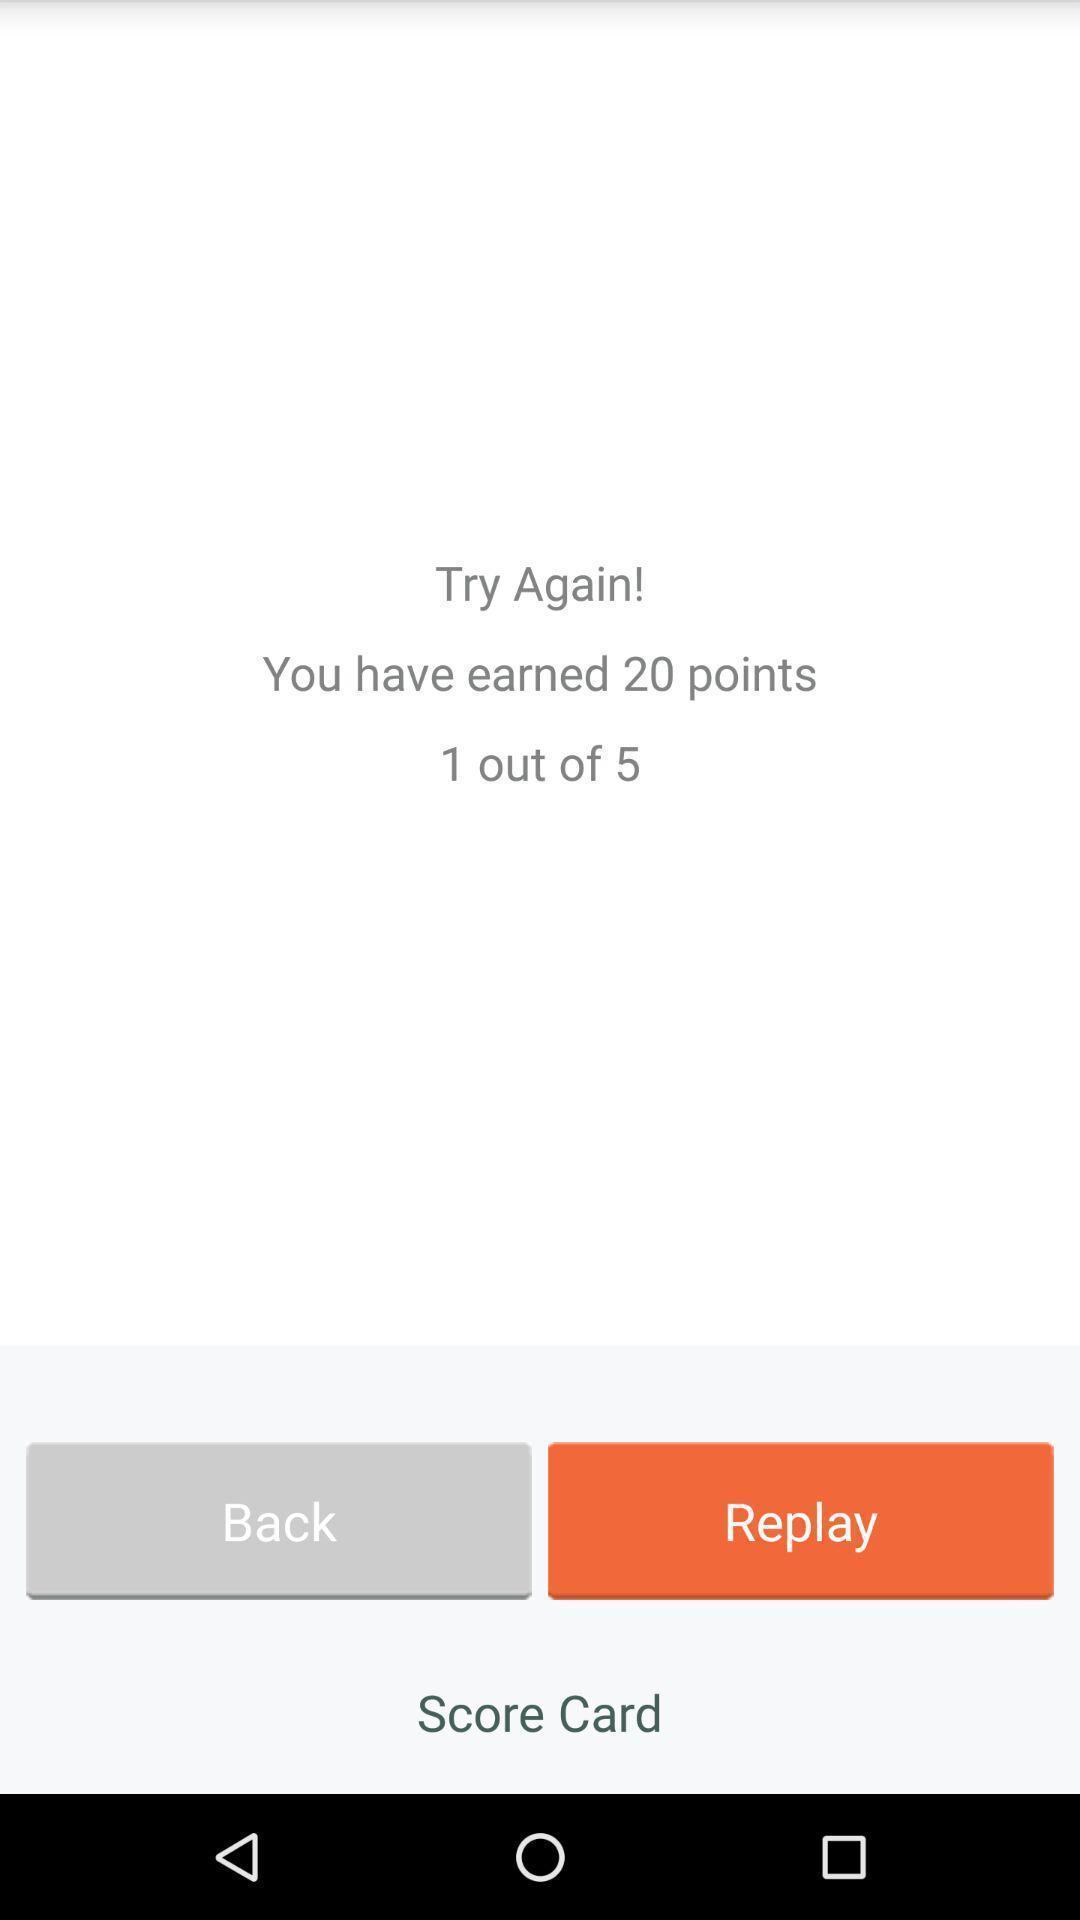Describe the content in this image. Screen shows number of points earned. 